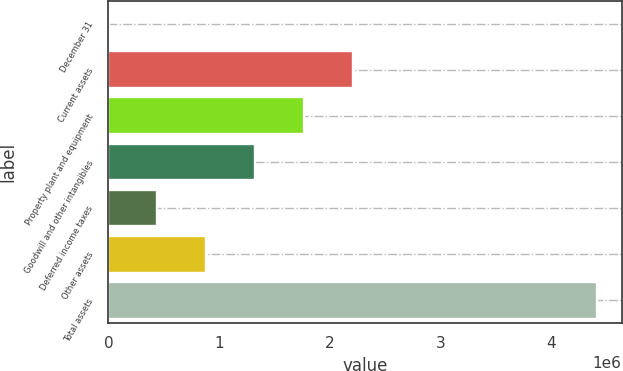Convert chart. <chart><loc_0><loc_0><loc_500><loc_500><bar_chart><fcel>December 31<fcel>Current assets<fcel>Property plant and equipment<fcel>Goodwill and other intangibles<fcel>Deferred income taxes<fcel>Other assets<fcel>Total assets<nl><fcel>2011<fcel>2.2071e+06<fcel>1.76609e+06<fcel>1.32507e+06<fcel>443030<fcel>884049<fcel>4.4122e+06<nl></chart> 